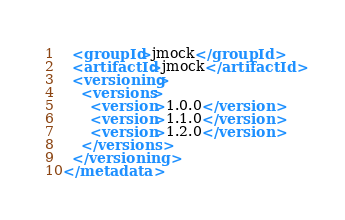<code> <loc_0><loc_0><loc_500><loc_500><_XML_>  <groupId>jmock</groupId>
  <artifactId>jmock</artifactId>
  <versioning>
    <versions>
      <version>1.0.0</version>
      <version>1.1.0</version>
      <version>1.2.0</version>
    </versions>
  </versioning>
</metadata>
</code> 